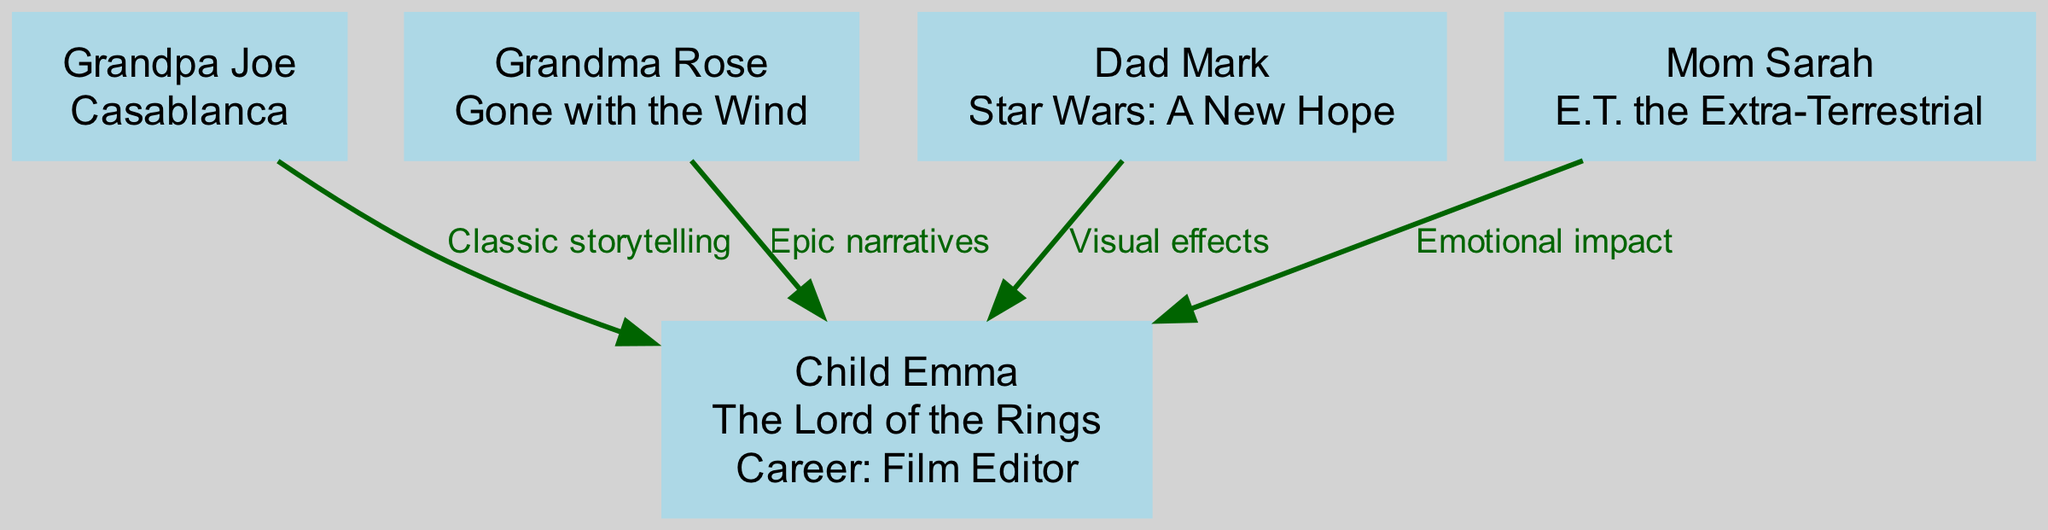What is Grandpa Joe's favorite movie? The diagram shows that Grandpa Joe's favorite movie is displayed as a label on his node. This information is directly available from the diagram.
Answer: Casablanca How many family members are there in total? By counting the nodes in the diagram, we see there are five family members depicted: Grandpa Joe, Grandma Rose, Dad Mark, Mom Sarah, and Child Emma.
Answer: 5 What influence did Dad Mark have on Child Emma? The diagram indicates the influence line from Dad Mark to Child Emma is labeled with "Visual effects." This label shows the specific influence Dad Mark had.
Answer: Visual effects Which movie is associated with Child Emma? Child Emma's node clearly lists her favorite movie, which is directly visible in the diagram as part of her labeling.
Answer: The Lord of the Rings Who influenced Child Emma with "Emotional impact"? The label on the influence from Mom Sarah to Child Emma specifically states "Emotional impact." This indicates that Mom Sarah was the influence providing this theme.
Answer: Mom Sarah What is the common theme among the influences towards Child Emma? By analyzing all influence lines toward Child Emma, it becomes clear that each influence contributes to a unique aspect of storytelling in film, which indicates a blend of classic, emotional, and technical elements.
Answer: Storytelling How many influences are there directed towards Child Emma? Checking the number of directed lines (edges) from family members to Child Emma, we find there are four instances of influence. This count can be directly obtained from the edges leading to Child Emma.
Answer: 4 Which family member's favorite movie has an "Epic narratives" influence? The influence labeled "Epic narratives" points from Grandma Rose to Child Emma, as shown in the connection established in the diagram.
Answer: Grandma Rose What career does Child Emma aspire to have? Child Emma's node includes a label with her career information, which is indicated directly in the diagram. Thus, it is easy to ascertain from her node.
Answer: Film Editor 